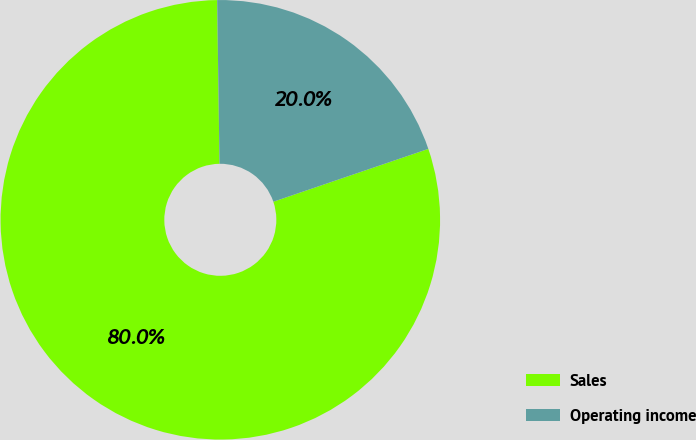Convert chart. <chart><loc_0><loc_0><loc_500><loc_500><pie_chart><fcel>Sales<fcel>Operating income<nl><fcel>80.0%<fcel>20.0%<nl></chart> 